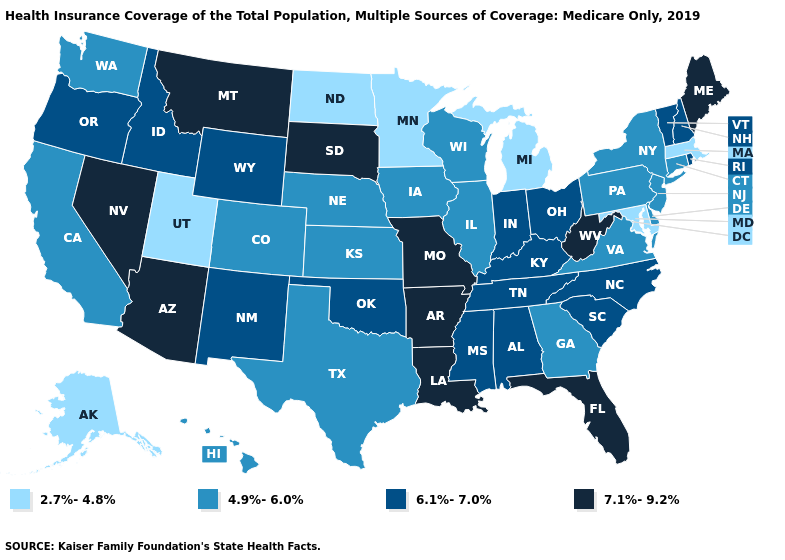What is the lowest value in states that border Ohio?
Short answer required. 2.7%-4.8%. What is the highest value in the USA?
Keep it brief. 7.1%-9.2%. Name the states that have a value in the range 7.1%-9.2%?
Concise answer only. Arizona, Arkansas, Florida, Louisiana, Maine, Missouri, Montana, Nevada, South Dakota, West Virginia. Does Florida have the same value as Michigan?
Short answer required. No. Which states hav the highest value in the Northeast?
Be succinct. Maine. Among the states that border Arizona , which have the lowest value?
Write a very short answer. Utah. Which states have the highest value in the USA?
Concise answer only. Arizona, Arkansas, Florida, Louisiana, Maine, Missouri, Montana, Nevada, South Dakota, West Virginia. Name the states that have a value in the range 2.7%-4.8%?
Keep it brief. Alaska, Maryland, Massachusetts, Michigan, Minnesota, North Dakota, Utah. Does Ohio have the highest value in the USA?
Write a very short answer. No. What is the highest value in the Northeast ?
Give a very brief answer. 7.1%-9.2%. Among the states that border Oregon , which have the lowest value?
Concise answer only. California, Washington. What is the highest value in states that border Connecticut?
Keep it brief. 6.1%-7.0%. Which states have the lowest value in the West?
Give a very brief answer. Alaska, Utah. Does Utah have the lowest value in the USA?
Give a very brief answer. Yes. Does Idaho have the lowest value in the West?
Concise answer only. No. 